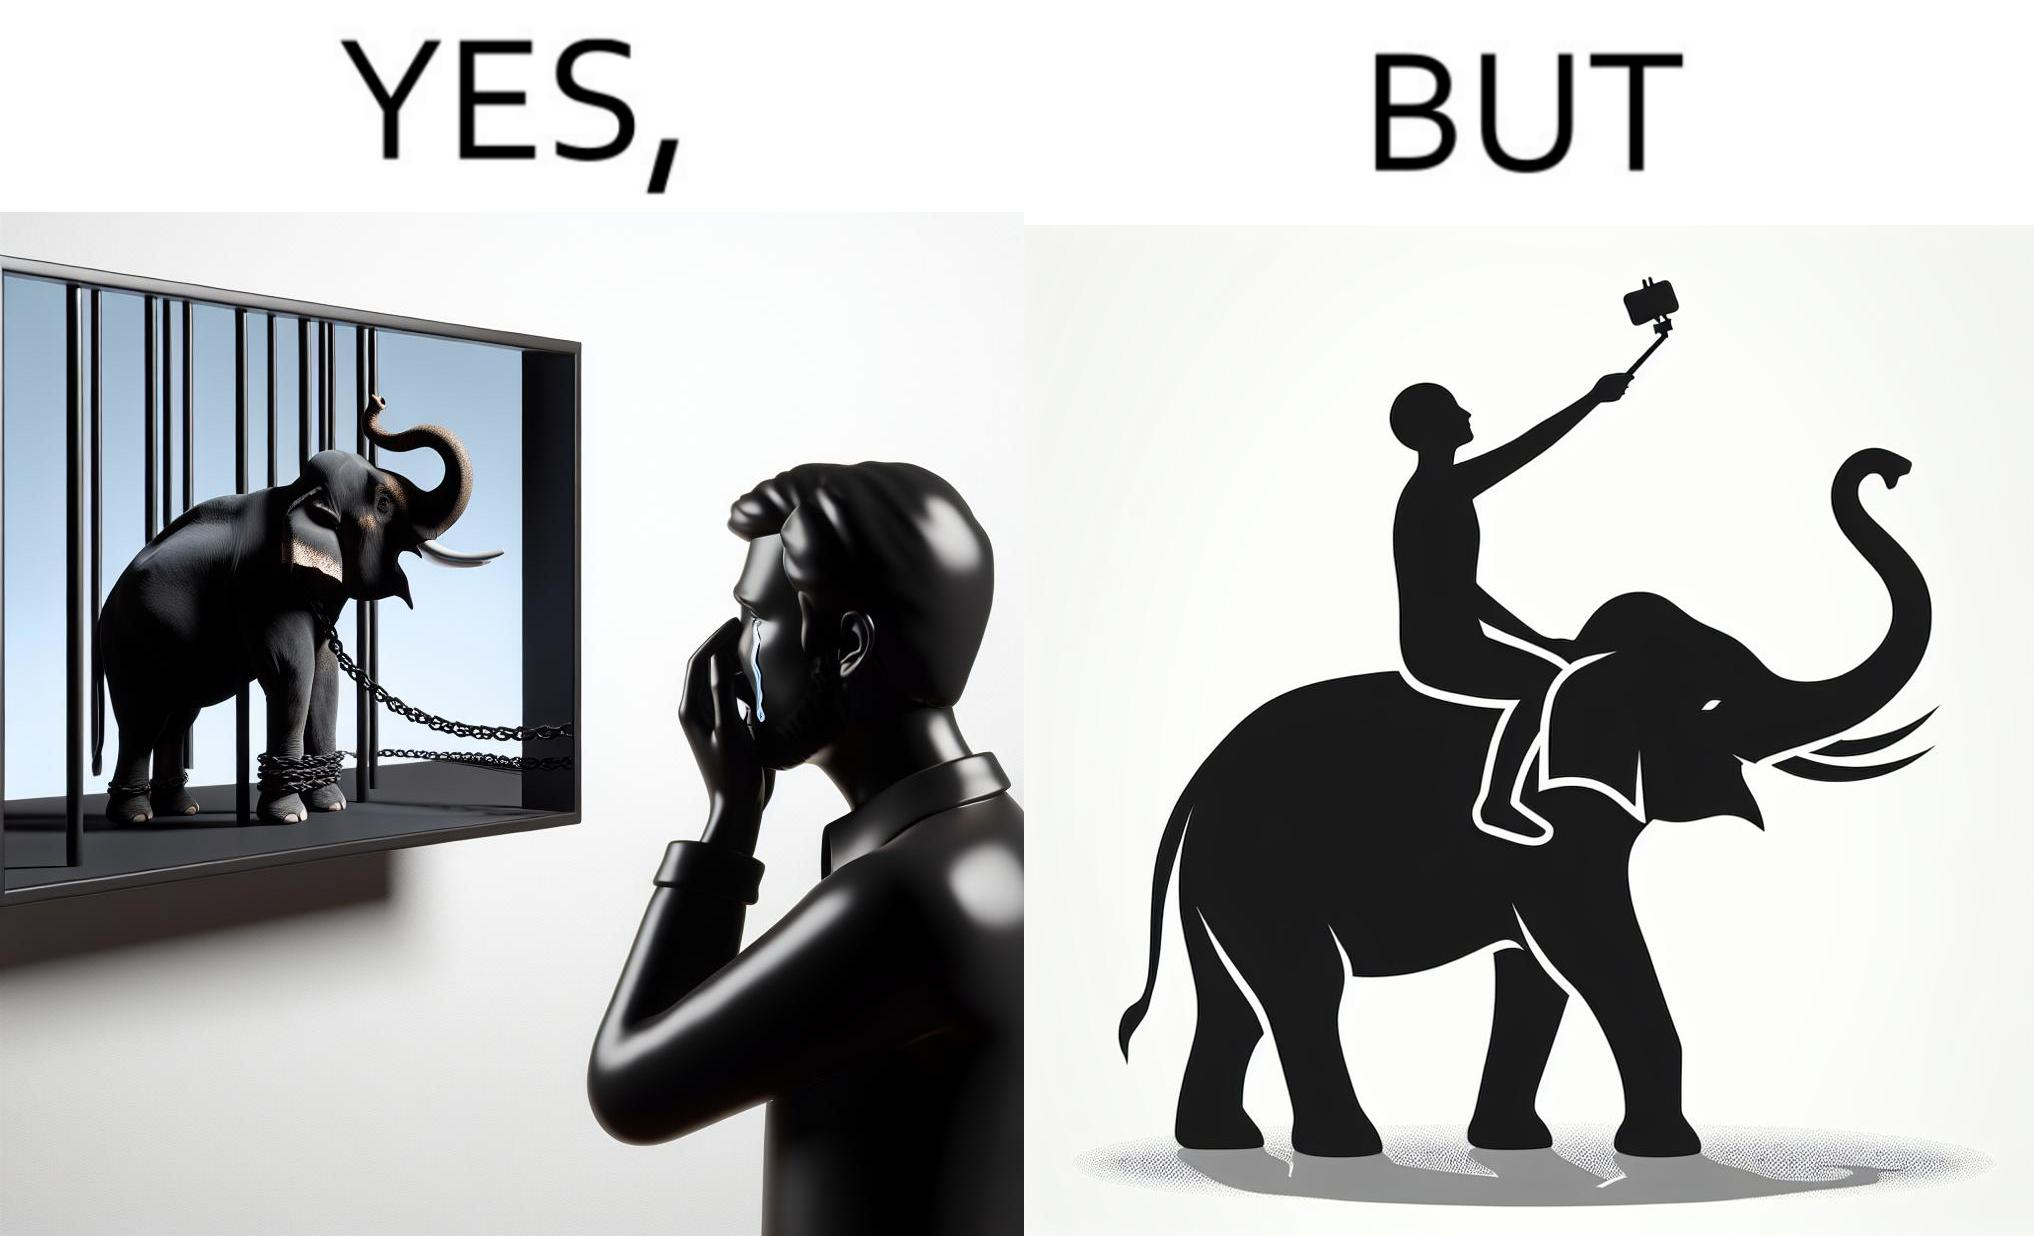What do you see in each half of this image? In the left part of the image: a man crying on seeing an elephant being chained in a cage in a TV program In the right part of the image: a person riding an elephant while taking selfies 